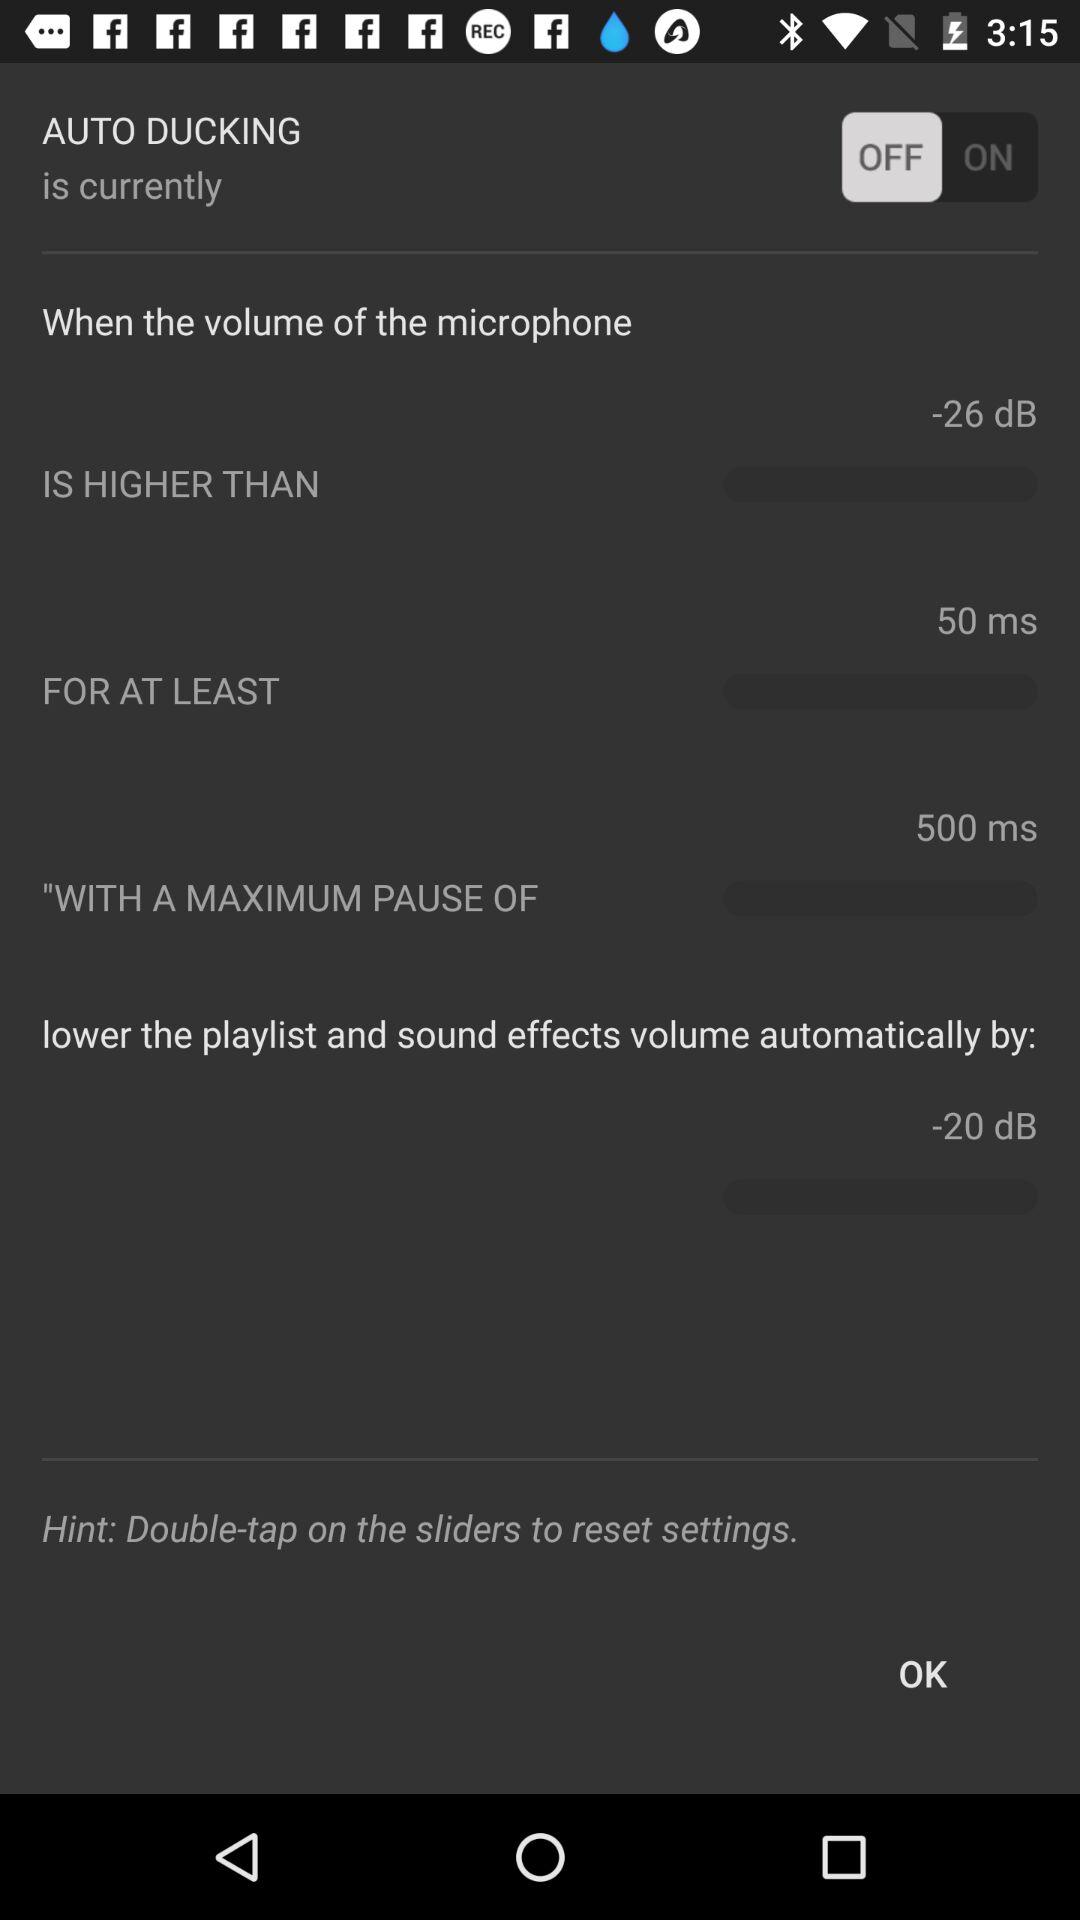What is the higher volume? The higher volume is -20 decibels. 